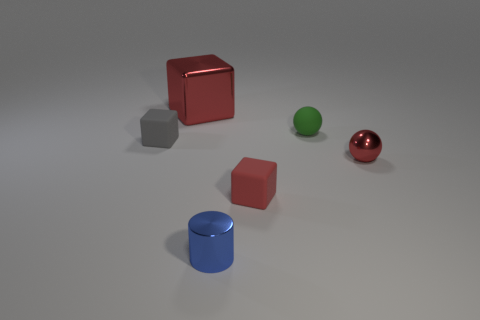Subtract all matte blocks. How many blocks are left? 1 Add 3 small balls. How many objects exist? 9 Subtract all spheres. How many objects are left? 4 Add 2 small cylinders. How many small cylinders are left? 3 Add 3 tiny purple matte cylinders. How many tiny purple matte cylinders exist? 3 Subtract 0 cyan blocks. How many objects are left? 6 Subtract all big metal objects. Subtract all small rubber blocks. How many objects are left? 3 